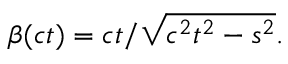Convert formula to latex. <formula><loc_0><loc_0><loc_500><loc_500>\beta ( c t ) = c t / { \sqrt { c ^ { 2 } t ^ { 2 } - s ^ { 2 } } } .</formula> 